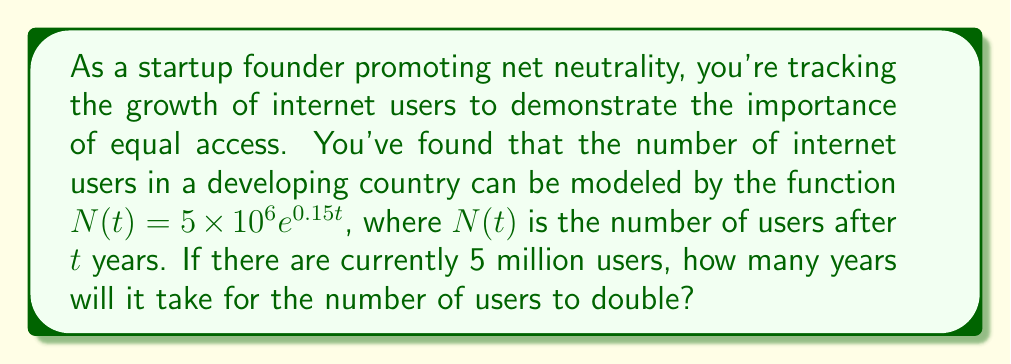Could you help me with this problem? Let's approach this step-by-step:

1) We're given the function $N(t) = 5 \times 10^6 e^{0.15t}$, where $N(t)$ is the number of users after $t$ years.

2) We're told there are currently 5 million users, which is our initial value. This means $N(0) = 5 \times 10^6$.

3) We want to find when the number of users doubles, so we're looking for $t$ when $N(t) = 2 \times 5 \times 10^6 = 10 \times 10^6$.

4) Let's set up the equation:

   $10 \times 10^6 = 5 \times 10^6 e^{0.15t}$

5) Divide both sides by $5 \times 10^6$:

   $2 = e^{0.15t}$

6) Take the natural log of both sides:

   $\ln(2) = \ln(e^{0.15t})$

7) Simplify the right side using the properties of logarithms:

   $\ln(2) = 0.15t$

8) Solve for $t$:

   $t = \frac{\ln(2)}{0.15}$

9) Calculate the result:

   $t \approx 4.62$ years
Answer: It will take approximately 4.62 years for the number of internet users to double. 